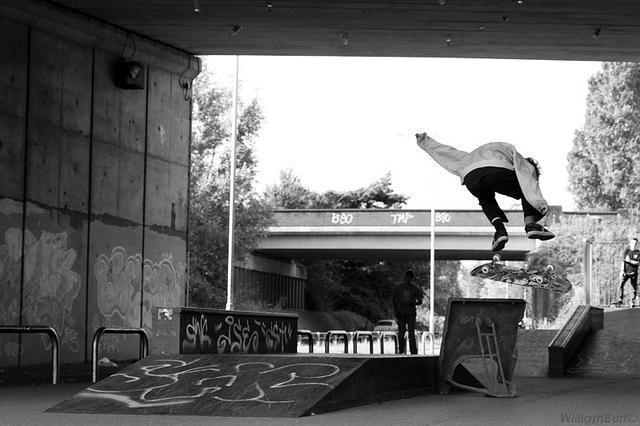How many graffiti pictures are on the overpass wall?
Indicate the correct response and explain using: 'Answer: answer
Rationale: rationale.'
Options: One, two, four, three. Answer: three.
Rationale: There are 3 pictures. 